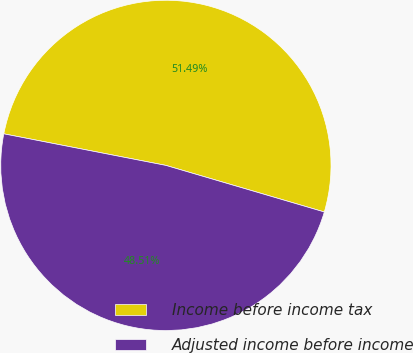Convert chart. <chart><loc_0><loc_0><loc_500><loc_500><pie_chart><fcel>Income before income tax<fcel>Adjusted income before income<nl><fcel>51.49%<fcel>48.51%<nl></chart> 